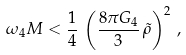<formula> <loc_0><loc_0><loc_500><loc_500>\omega _ { 4 } M < \frac { 1 } { 4 } \, \left ( \frac { 8 \pi G _ { 4 } } { 3 } \, \tilde { \rho } \right ) ^ { 2 } \, ,</formula> 